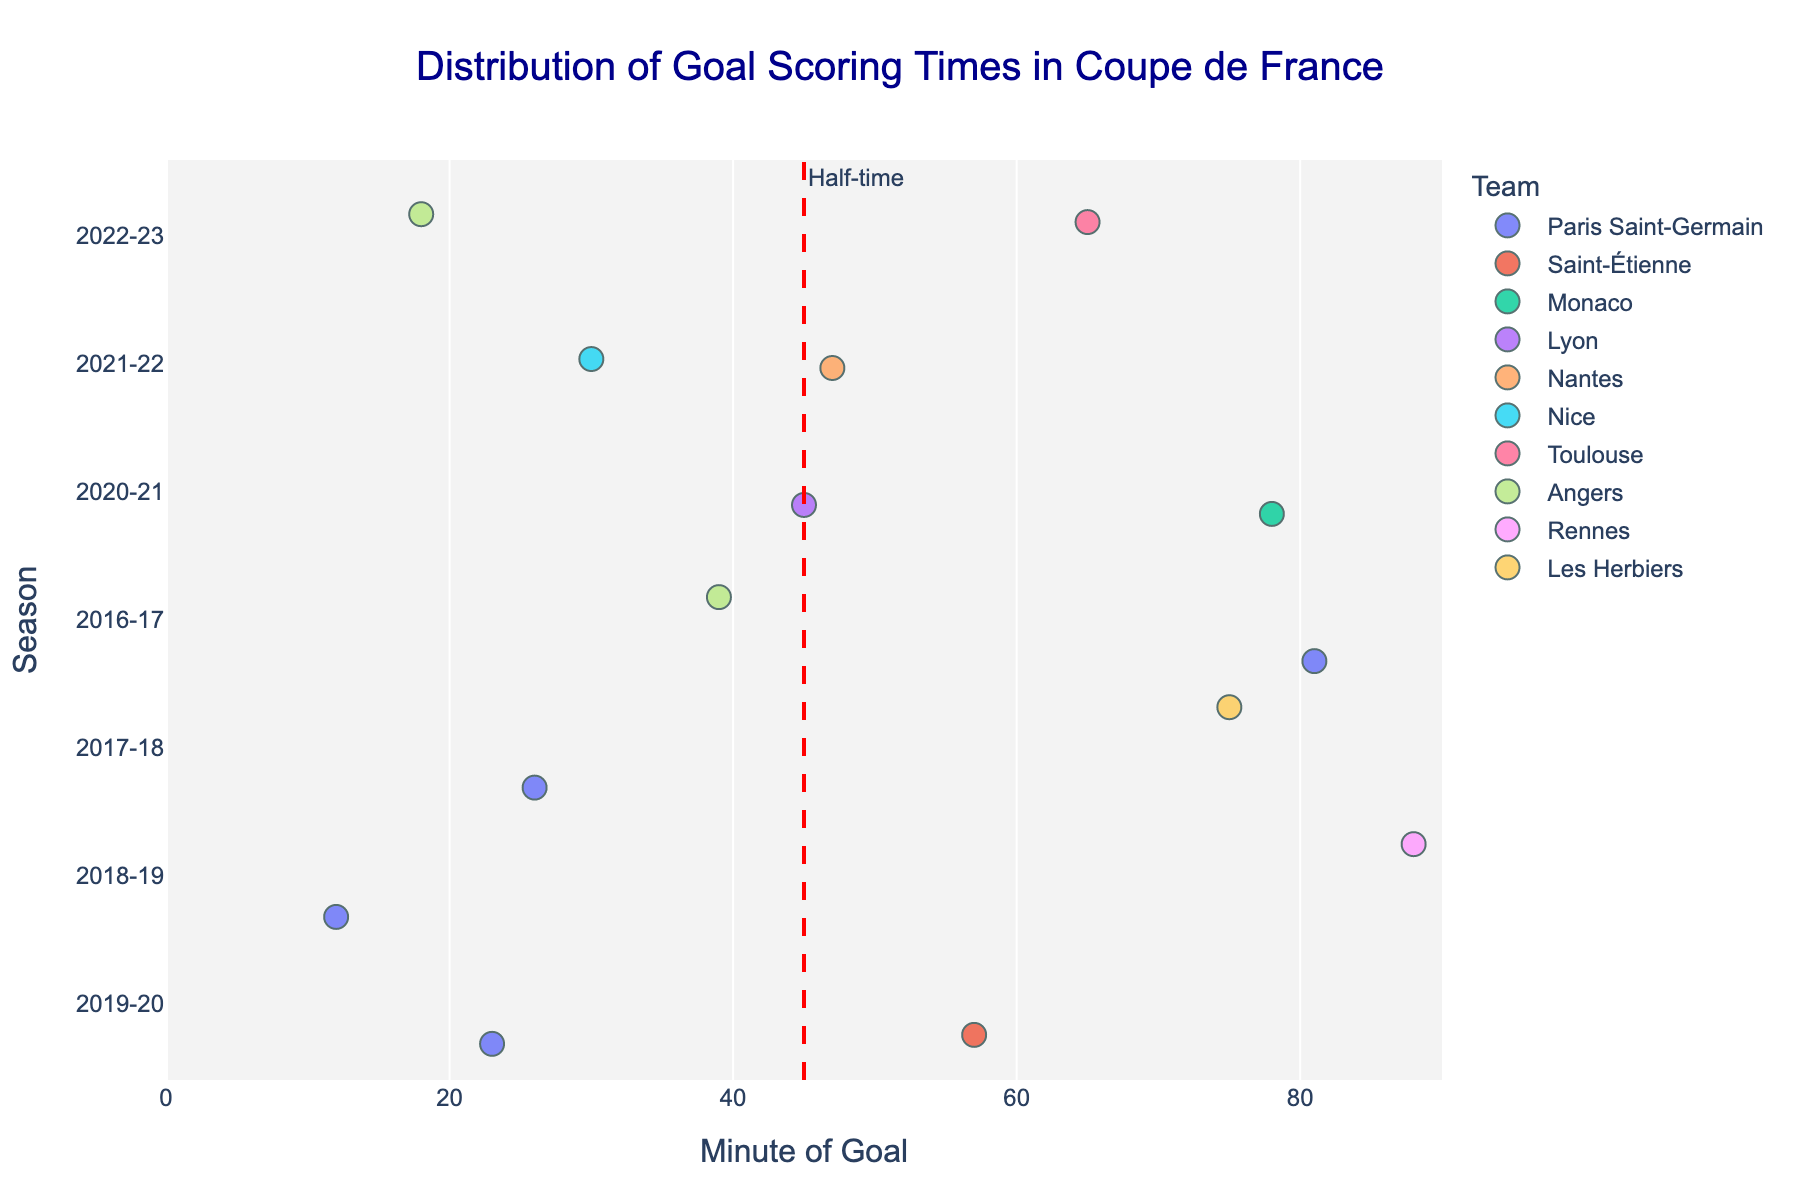What's the title of the plot? The title is prominently displayed at the top of the plot in a large font size and dark blue color.
Answer: Distribution of Goal Scoring Times in Coupe de France How many different seasons are represented in the plot? Each unique y-axis label corresponds to a different season. Count the distinct labels from 2016-17 to 2022-23.
Answer: 7 Which player scored the earliest goal, and what minute was it? Find the point on the x-axis closest to zero and hover to see the player information.
Answer: Neymar, 12th minute Which team has the most players represented in the plot? Identify which color (team) appears most frequently across all seasons.
Answer: Paris Saint-Germain Are there any goals scored right before half-time (around the 45th minute)? Look for points close to the red dashed vertical line marking 45 minutes. Hover over them to identify the goal minutes.
Answer: Yes, Moussa Dembélé (45th minute) What is the median goal minute across all seasons? List all goal minutes, arrange in ascending order, and find the middle value. There are 14 data points: (12, 18, 23, 26, 30, 39, 45, 47, 57, 65, 75, 78, 81, 88). Take the 7th and 8th data points, average them: (45+47)/2.
Answer: 46 Which team scored the latest goal in the dataset? Identify the point furthest to the right on the x-axis and hover to see the team information.
Answer: Rennes How many goals were scored after the 80th minute? Count the number of points to the right of the 80-minute mark on the x-axis.
Answer: 2 In which season did Paris Saint-Germain have the highest number of goals? Look for the season where Paris Saint-Germain appears most frequently when colored points are grouped by y-axis season labels.
Answer: 2017-18 Did any goals occur at exactly half-time (45th minute mark)? Look for a point exactly labeled 45 on the x-axis and check hover details for confirmation.
Answer: Yes, Moussa Dembélé 